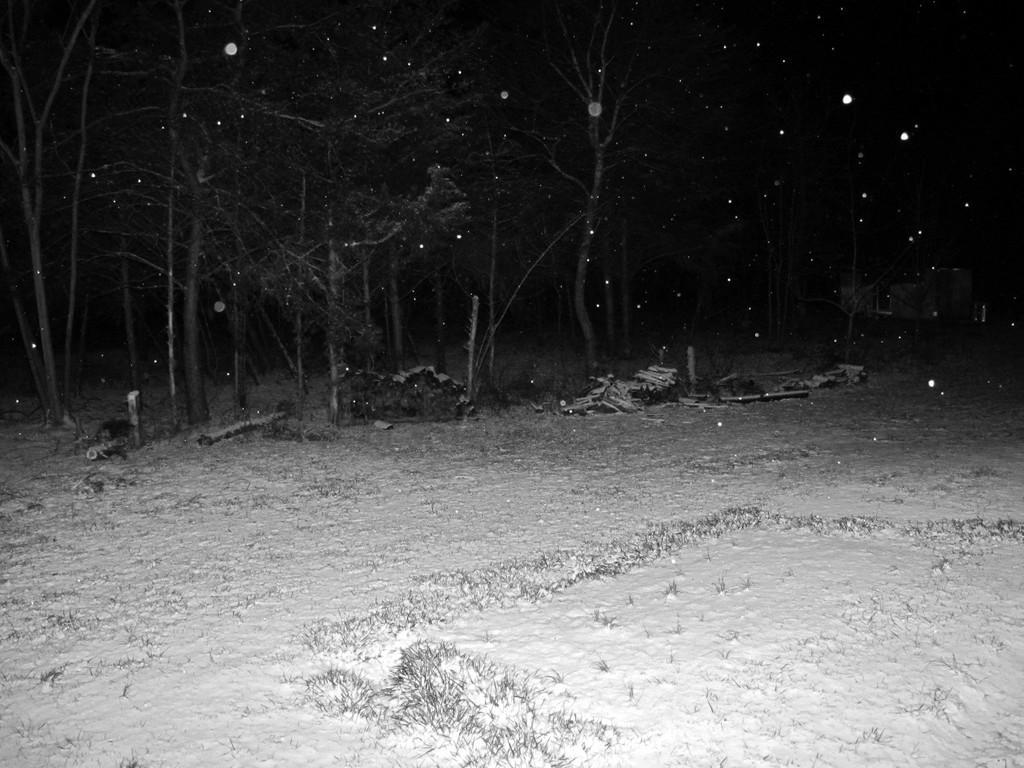In one or two sentences, can you explain what this image depicts? In this picture we can see the grass, snow, trees, wooden sticks and some objects and in the background it is dark. 